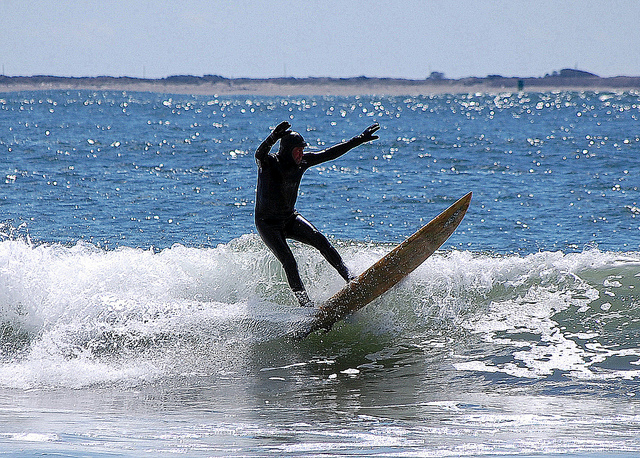<image>Will this person fall down? I am not sure if this person will fall down. Will this person fall down? I don't know if this person will fall down. It is possible but not certain. 